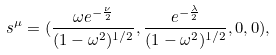Convert formula to latex. <formula><loc_0><loc_0><loc_500><loc_500>s ^ { \mu } = ( \frac { \omega e ^ { - \frac { \nu } { 2 } } } { ( 1 - \omega ^ { 2 } ) ^ { 1 / 2 } } , \frac { e ^ { - \frac { \lambda } { 2 } } } { ( 1 - \omega ^ { 2 } ) ^ { 1 / 2 } } , 0 , 0 ) ,</formula> 